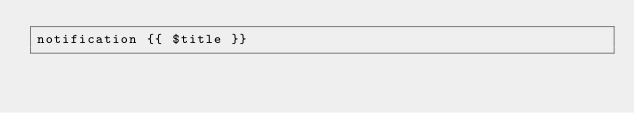Convert code to text. <code><loc_0><loc_0><loc_500><loc_500><_PHP_>notification {{ $title }}</code> 